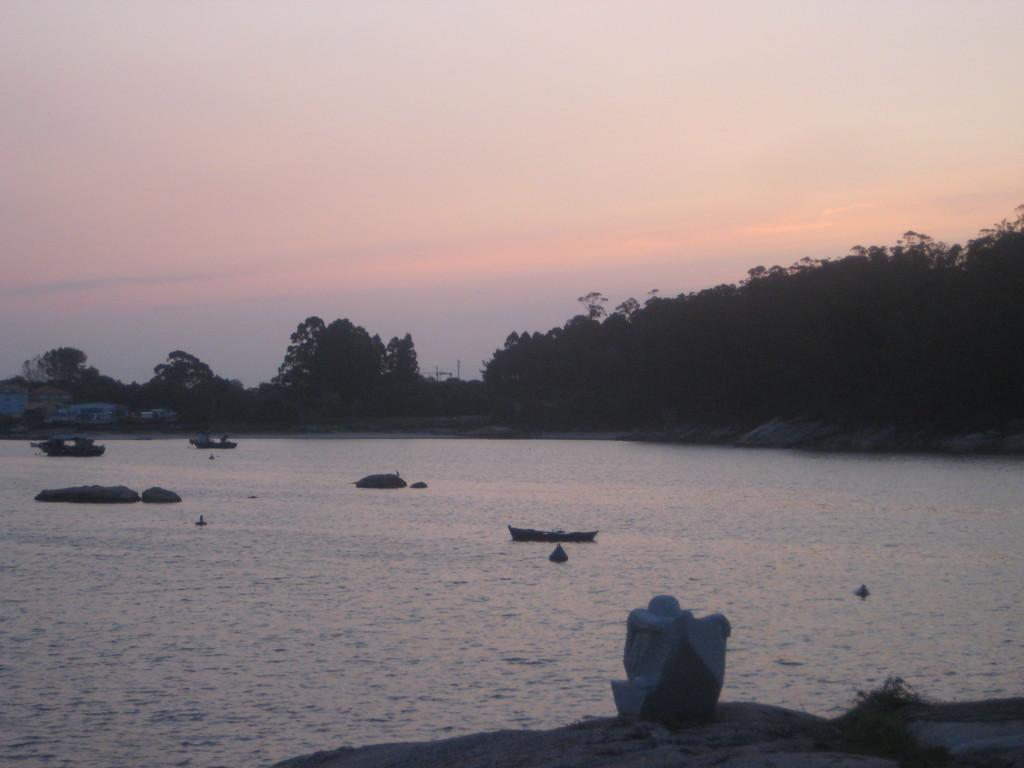What is the main subject of the image? The main subject of the image is boats. What is the boats situated in? The boats are situated in water, which is visible in the image. What can be seen in the background of the image? In the background of the image, there are trees and poles. How would you describe the sky in the image? The sky in the image is a combination of white and blue colors. What suggestion does your friend make about the boats in the image? There is no friend present in the image, and therefore no suggestion can be attributed to them. 